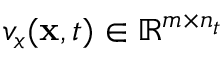<formula> <loc_0><loc_0><loc_500><loc_500>v _ { x } ( x , t ) \in \mathbb { R } ^ { m \times n _ { t } }</formula> 